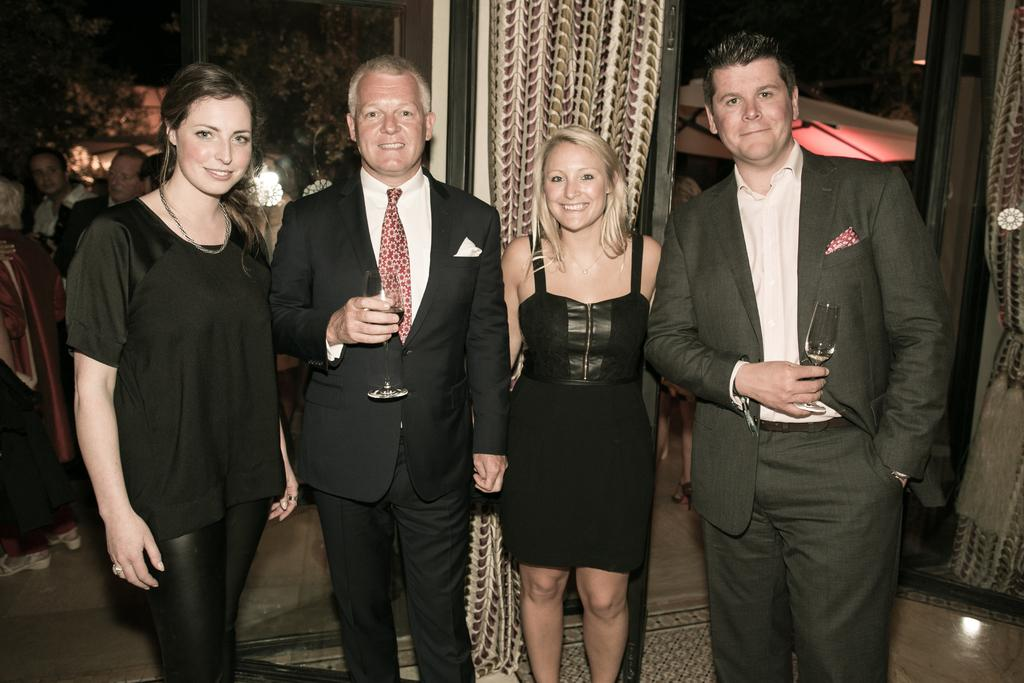How many men and women are present in the image? There are two men and two women in the image. What are the men holding in the image? The men are holding glasses in the image. Can you describe the background of the image? There are people and curtains in the background of the image. What type of poison is being served in the glasses held by the men in the image? There is no indication of poison in the image; the men are holding glasses, but their contents are not specified. How much rice is visible on the table in the image? There is no rice present in the image. 